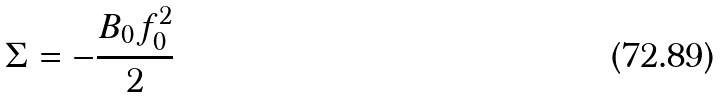Convert formula to latex. <formula><loc_0><loc_0><loc_500><loc_500>\Sigma = - \frac { B _ { 0 } f _ { 0 } ^ { 2 } } { 2 }</formula> 